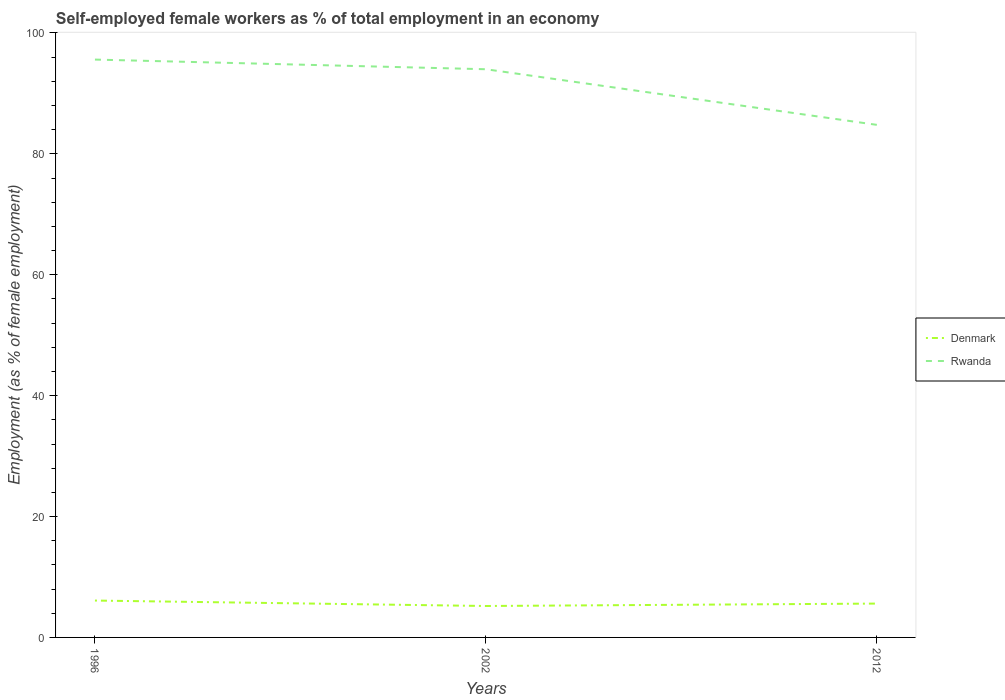Does the line corresponding to Rwanda intersect with the line corresponding to Denmark?
Provide a short and direct response. No. Across all years, what is the maximum percentage of self-employed female workers in Rwanda?
Give a very brief answer. 84.8. In which year was the percentage of self-employed female workers in Rwanda maximum?
Keep it short and to the point. 2012. What is the total percentage of self-employed female workers in Denmark in the graph?
Offer a terse response. -0.4. What is the difference between the highest and the second highest percentage of self-employed female workers in Rwanda?
Your answer should be very brief. 10.8. What is the difference between the highest and the lowest percentage of self-employed female workers in Rwanda?
Give a very brief answer. 2. Is the percentage of self-employed female workers in Denmark strictly greater than the percentage of self-employed female workers in Rwanda over the years?
Your answer should be very brief. Yes. How many years are there in the graph?
Provide a succinct answer. 3. What is the difference between two consecutive major ticks on the Y-axis?
Your answer should be very brief. 20. Does the graph contain any zero values?
Keep it short and to the point. No. Where does the legend appear in the graph?
Your response must be concise. Center right. How many legend labels are there?
Your response must be concise. 2. What is the title of the graph?
Provide a succinct answer. Self-employed female workers as % of total employment in an economy. What is the label or title of the Y-axis?
Your response must be concise. Employment (as % of female employment). What is the Employment (as % of female employment) of Denmark in 1996?
Your answer should be very brief. 6.1. What is the Employment (as % of female employment) in Rwanda in 1996?
Keep it short and to the point. 95.6. What is the Employment (as % of female employment) in Denmark in 2002?
Provide a succinct answer. 5.2. What is the Employment (as % of female employment) of Rwanda in 2002?
Give a very brief answer. 94. What is the Employment (as % of female employment) of Denmark in 2012?
Your answer should be compact. 5.6. What is the Employment (as % of female employment) of Rwanda in 2012?
Give a very brief answer. 84.8. Across all years, what is the maximum Employment (as % of female employment) in Denmark?
Provide a succinct answer. 6.1. Across all years, what is the maximum Employment (as % of female employment) of Rwanda?
Give a very brief answer. 95.6. Across all years, what is the minimum Employment (as % of female employment) of Denmark?
Your answer should be very brief. 5.2. Across all years, what is the minimum Employment (as % of female employment) of Rwanda?
Provide a succinct answer. 84.8. What is the total Employment (as % of female employment) in Rwanda in the graph?
Make the answer very short. 274.4. What is the difference between the Employment (as % of female employment) of Rwanda in 1996 and that in 2002?
Your answer should be compact. 1.6. What is the difference between the Employment (as % of female employment) of Rwanda in 1996 and that in 2012?
Your answer should be compact. 10.8. What is the difference between the Employment (as % of female employment) in Rwanda in 2002 and that in 2012?
Your answer should be compact. 9.2. What is the difference between the Employment (as % of female employment) in Denmark in 1996 and the Employment (as % of female employment) in Rwanda in 2002?
Ensure brevity in your answer.  -87.9. What is the difference between the Employment (as % of female employment) of Denmark in 1996 and the Employment (as % of female employment) of Rwanda in 2012?
Your response must be concise. -78.7. What is the difference between the Employment (as % of female employment) of Denmark in 2002 and the Employment (as % of female employment) of Rwanda in 2012?
Ensure brevity in your answer.  -79.6. What is the average Employment (as % of female employment) of Denmark per year?
Offer a terse response. 5.63. What is the average Employment (as % of female employment) of Rwanda per year?
Give a very brief answer. 91.47. In the year 1996, what is the difference between the Employment (as % of female employment) in Denmark and Employment (as % of female employment) in Rwanda?
Provide a short and direct response. -89.5. In the year 2002, what is the difference between the Employment (as % of female employment) of Denmark and Employment (as % of female employment) of Rwanda?
Offer a terse response. -88.8. In the year 2012, what is the difference between the Employment (as % of female employment) of Denmark and Employment (as % of female employment) of Rwanda?
Ensure brevity in your answer.  -79.2. What is the ratio of the Employment (as % of female employment) of Denmark in 1996 to that in 2002?
Your answer should be compact. 1.17. What is the ratio of the Employment (as % of female employment) in Denmark in 1996 to that in 2012?
Give a very brief answer. 1.09. What is the ratio of the Employment (as % of female employment) in Rwanda in 1996 to that in 2012?
Your response must be concise. 1.13. What is the ratio of the Employment (as % of female employment) in Denmark in 2002 to that in 2012?
Your response must be concise. 0.93. What is the ratio of the Employment (as % of female employment) of Rwanda in 2002 to that in 2012?
Ensure brevity in your answer.  1.11. What is the difference between the highest and the second highest Employment (as % of female employment) of Denmark?
Your response must be concise. 0.5. What is the difference between the highest and the lowest Employment (as % of female employment) in Denmark?
Ensure brevity in your answer.  0.9. 